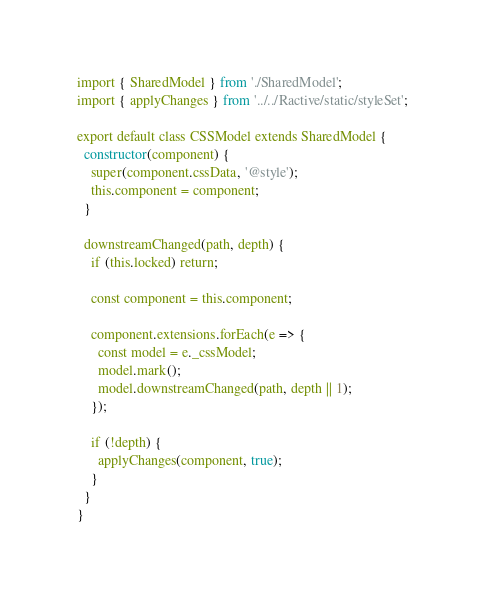<code> <loc_0><loc_0><loc_500><loc_500><_JavaScript_>import { SharedModel } from './SharedModel';
import { applyChanges } from '../../Ractive/static/styleSet';

export default class CSSModel extends SharedModel {
  constructor(component) {
    super(component.cssData, '@style');
    this.component = component;
  }

  downstreamChanged(path, depth) {
    if (this.locked) return;

    const component = this.component;

    component.extensions.forEach(e => {
      const model = e._cssModel;
      model.mark();
      model.downstreamChanged(path, depth || 1);
    });

    if (!depth) {
      applyChanges(component, true);
    }
  }
}
</code> 